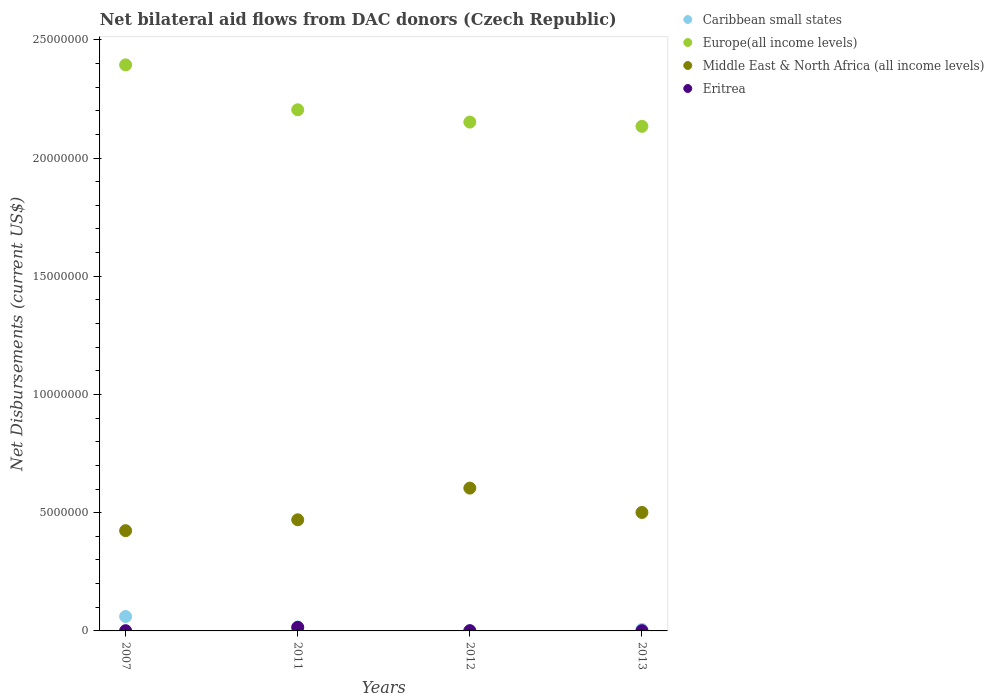Is the number of dotlines equal to the number of legend labels?
Give a very brief answer. Yes. Across all years, what is the maximum net bilateral aid flows in Europe(all income levels)?
Provide a short and direct response. 2.39e+07. Across all years, what is the minimum net bilateral aid flows in Europe(all income levels)?
Ensure brevity in your answer.  2.13e+07. In which year was the net bilateral aid flows in Europe(all income levels) maximum?
Offer a terse response. 2007. What is the total net bilateral aid flows in Middle East & North Africa (all income levels) in the graph?
Make the answer very short. 2.00e+07. What is the difference between the net bilateral aid flows in Europe(all income levels) in 2012 and that in 2013?
Offer a terse response. 1.80e+05. What is the difference between the net bilateral aid flows in Europe(all income levels) in 2012 and the net bilateral aid flows in Caribbean small states in 2007?
Keep it short and to the point. 2.09e+07. What is the average net bilateral aid flows in Eritrea per year?
Your answer should be compact. 4.50e+04. In the year 2011, what is the difference between the net bilateral aid flows in Europe(all income levels) and net bilateral aid flows in Middle East & North Africa (all income levels)?
Your response must be concise. 1.73e+07. In how many years, is the net bilateral aid flows in Eritrea greater than 4000000 US$?
Your answer should be compact. 0. What is the ratio of the net bilateral aid flows in Caribbean small states in 2007 to that in 2012?
Provide a succinct answer. 61. Is the net bilateral aid flows in Middle East & North Africa (all income levels) in 2007 less than that in 2011?
Ensure brevity in your answer.  Yes. What is the difference between the highest and the second highest net bilateral aid flows in Middle East & North Africa (all income levels)?
Ensure brevity in your answer.  1.03e+06. In how many years, is the net bilateral aid flows in Europe(all income levels) greater than the average net bilateral aid flows in Europe(all income levels) taken over all years?
Give a very brief answer. 1. Is the sum of the net bilateral aid flows in Middle East & North Africa (all income levels) in 2011 and 2013 greater than the maximum net bilateral aid flows in Europe(all income levels) across all years?
Offer a very short reply. No. Is it the case that in every year, the sum of the net bilateral aid flows in Middle East & North Africa (all income levels) and net bilateral aid flows in Europe(all income levels)  is greater than the sum of net bilateral aid flows in Eritrea and net bilateral aid flows in Caribbean small states?
Your answer should be compact. Yes. Does the net bilateral aid flows in Middle East & North Africa (all income levels) monotonically increase over the years?
Keep it short and to the point. No. Is the net bilateral aid flows in Europe(all income levels) strictly less than the net bilateral aid flows in Caribbean small states over the years?
Provide a short and direct response. No. How many dotlines are there?
Your answer should be very brief. 4. How many years are there in the graph?
Offer a terse response. 4. What is the difference between two consecutive major ticks on the Y-axis?
Your response must be concise. 5.00e+06. Are the values on the major ticks of Y-axis written in scientific E-notation?
Make the answer very short. No. Where does the legend appear in the graph?
Keep it short and to the point. Top right. How are the legend labels stacked?
Your answer should be compact. Vertical. What is the title of the graph?
Keep it short and to the point. Net bilateral aid flows from DAC donors (Czech Republic). Does "Jamaica" appear as one of the legend labels in the graph?
Provide a succinct answer. No. What is the label or title of the Y-axis?
Make the answer very short. Net Disbursements (current US$). What is the Net Disbursements (current US$) of Caribbean small states in 2007?
Make the answer very short. 6.10e+05. What is the Net Disbursements (current US$) in Europe(all income levels) in 2007?
Your answer should be very brief. 2.39e+07. What is the Net Disbursements (current US$) of Middle East & North Africa (all income levels) in 2007?
Ensure brevity in your answer.  4.24e+06. What is the Net Disbursements (current US$) of Europe(all income levels) in 2011?
Your response must be concise. 2.20e+07. What is the Net Disbursements (current US$) of Middle East & North Africa (all income levels) in 2011?
Provide a short and direct response. 4.70e+06. What is the Net Disbursements (current US$) of Caribbean small states in 2012?
Offer a terse response. 10000. What is the Net Disbursements (current US$) in Europe(all income levels) in 2012?
Offer a terse response. 2.15e+07. What is the Net Disbursements (current US$) in Middle East & North Africa (all income levels) in 2012?
Provide a succinct answer. 6.04e+06. What is the Net Disbursements (current US$) of Eritrea in 2012?
Offer a terse response. 10000. What is the Net Disbursements (current US$) in Caribbean small states in 2013?
Ensure brevity in your answer.  6.00e+04. What is the Net Disbursements (current US$) in Europe(all income levels) in 2013?
Provide a succinct answer. 2.13e+07. What is the Net Disbursements (current US$) of Middle East & North Africa (all income levels) in 2013?
Offer a very short reply. 5.01e+06. What is the Net Disbursements (current US$) in Eritrea in 2013?
Ensure brevity in your answer.  10000. Across all years, what is the maximum Net Disbursements (current US$) of Europe(all income levels)?
Provide a succinct answer. 2.39e+07. Across all years, what is the maximum Net Disbursements (current US$) of Middle East & North Africa (all income levels)?
Keep it short and to the point. 6.04e+06. Across all years, what is the minimum Net Disbursements (current US$) of Europe(all income levels)?
Your response must be concise. 2.13e+07. Across all years, what is the minimum Net Disbursements (current US$) in Middle East & North Africa (all income levels)?
Provide a short and direct response. 4.24e+06. What is the total Net Disbursements (current US$) of Caribbean small states in the graph?
Offer a terse response. 8.50e+05. What is the total Net Disbursements (current US$) of Europe(all income levels) in the graph?
Provide a succinct answer. 8.88e+07. What is the total Net Disbursements (current US$) of Middle East & North Africa (all income levels) in the graph?
Ensure brevity in your answer.  2.00e+07. What is the difference between the Net Disbursements (current US$) in Europe(all income levels) in 2007 and that in 2011?
Your answer should be very brief. 1.90e+06. What is the difference between the Net Disbursements (current US$) of Middle East & North Africa (all income levels) in 2007 and that in 2011?
Keep it short and to the point. -4.60e+05. What is the difference between the Net Disbursements (current US$) in Eritrea in 2007 and that in 2011?
Your answer should be compact. -1.40e+05. What is the difference between the Net Disbursements (current US$) in Europe(all income levels) in 2007 and that in 2012?
Provide a short and direct response. 2.42e+06. What is the difference between the Net Disbursements (current US$) in Middle East & North Africa (all income levels) in 2007 and that in 2012?
Your response must be concise. -1.80e+06. What is the difference between the Net Disbursements (current US$) of Eritrea in 2007 and that in 2012?
Make the answer very short. 0. What is the difference between the Net Disbursements (current US$) in Caribbean small states in 2007 and that in 2013?
Your answer should be very brief. 5.50e+05. What is the difference between the Net Disbursements (current US$) in Europe(all income levels) in 2007 and that in 2013?
Offer a terse response. 2.60e+06. What is the difference between the Net Disbursements (current US$) in Middle East & North Africa (all income levels) in 2007 and that in 2013?
Offer a terse response. -7.70e+05. What is the difference between the Net Disbursements (current US$) in Europe(all income levels) in 2011 and that in 2012?
Provide a succinct answer. 5.20e+05. What is the difference between the Net Disbursements (current US$) of Middle East & North Africa (all income levels) in 2011 and that in 2012?
Keep it short and to the point. -1.34e+06. What is the difference between the Net Disbursements (current US$) of Europe(all income levels) in 2011 and that in 2013?
Offer a terse response. 7.00e+05. What is the difference between the Net Disbursements (current US$) in Middle East & North Africa (all income levels) in 2011 and that in 2013?
Provide a succinct answer. -3.10e+05. What is the difference between the Net Disbursements (current US$) in Caribbean small states in 2012 and that in 2013?
Offer a terse response. -5.00e+04. What is the difference between the Net Disbursements (current US$) in Middle East & North Africa (all income levels) in 2012 and that in 2013?
Give a very brief answer. 1.03e+06. What is the difference between the Net Disbursements (current US$) of Caribbean small states in 2007 and the Net Disbursements (current US$) of Europe(all income levels) in 2011?
Your answer should be very brief. -2.14e+07. What is the difference between the Net Disbursements (current US$) in Caribbean small states in 2007 and the Net Disbursements (current US$) in Middle East & North Africa (all income levels) in 2011?
Offer a very short reply. -4.09e+06. What is the difference between the Net Disbursements (current US$) in Caribbean small states in 2007 and the Net Disbursements (current US$) in Eritrea in 2011?
Your response must be concise. 4.60e+05. What is the difference between the Net Disbursements (current US$) of Europe(all income levels) in 2007 and the Net Disbursements (current US$) of Middle East & North Africa (all income levels) in 2011?
Offer a terse response. 1.92e+07. What is the difference between the Net Disbursements (current US$) of Europe(all income levels) in 2007 and the Net Disbursements (current US$) of Eritrea in 2011?
Your response must be concise. 2.38e+07. What is the difference between the Net Disbursements (current US$) in Middle East & North Africa (all income levels) in 2007 and the Net Disbursements (current US$) in Eritrea in 2011?
Make the answer very short. 4.09e+06. What is the difference between the Net Disbursements (current US$) in Caribbean small states in 2007 and the Net Disbursements (current US$) in Europe(all income levels) in 2012?
Keep it short and to the point. -2.09e+07. What is the difference between the Net Disbursements (current US$) in Caribbean small states in 2007 and the Net Disbursements (current US$) in Middle East & North Africa (all income levels) in 2012?
Your response must be concise. -5.43e+06. What is the difference between the Net Disbursements (current US$) in Europe(all income levels) in 2007 and the Net Disbursements (current US$) in Middle East & North Africa (all income levels) in 2012?
Give a very brief answer. 1.79e+07. What is the difference between the Net Disbursements (current US$) of Europe(all income levels) in 2007 and the Net Disbursements (current US$) of Eritrea in 2012?
Provide a succinct answer. 2.39e+07. What is the difference between the Net Disbursements (current US$) of Middle East & North Africa (all income levels) in 2007 and the Net Disbursements (current US$) of Eritrea in 2012?
Make the answer very short. 4.23e+06. What is the difference between the Net Disbursements (current US$) of Caribbean small states in 2007 and the Net Disbursements (current US$) of Europe(all income levels) in 2013?
Keep it short and to the point. -2.07e+07. What is the difference between the Net Disbursements (current US$) in Caribbean small states in 2007 and the Net Disbursements (current US$) in Middle East & North Africa (all income levels) in 2013?
Provide a succinct answer. -4.40e+06. What is the difference between the Net Disbursements (current US$) of Caribbean small states in 2007 and the Net Disbursements (current US$) of Eritrea in 2013?
Your response must be concise. 6.00e+05. What is the difference between the Net Disbursements (current US$) of Europe(all income levels) in 2007 and the Net Disbursements (current US$) of Middle East & North Africa (all income levels) in 2013?
Offer a terse response. 1.89e+07. What is the difference between the Net Disbursements (current US$) of Europe(all income levels) in 2007 and the Net Disbursements (current US$) of Eritrea in 2013?
Give a very brief answer. 2.39e+07. What is the difference between the Net Disbursements (current US$) of Middle East & North Africa (all income levels) in 2007 and the Net Disbursements (current US$) of Eritrea in 2013?
Keep it short and to the point. 4.23e+06. What is the difference between the Net Disbursements (current US$) in Caribbean small states in 2011 and the Net Disbursements (current US$) in Europe(all income levels) in 2012?
Offer a terse response. -2.14e+07. What is the difference between the Net Disbursements (current US$) in Caribbean small states in 2011 and the Net Disbursements (current US$) in Middle East & North Africa (all income levels) in 2012?
Your answer should be very brief. -5.87e+06. What is the difference between the Net Disbursements (current US$) in Europe(all income levels) in 2011 and the Net Disbursements (current US$) in Middle East & North Africa (all income levels) in 2012?
Offer a terse response. 1.60e+07. What is the difference between the Net Disbursements (current US$) of Europe(all income levels) in 2011 and the Net Disbursements (current US$) of Eritrea in 2012?
Offer a very short reply. 2.20e+07. What is the difference between the Net Disbursements (current US$) in Middle East & North Africa (all income levels) in 2011 and the Net Disbursements (current US$) in Eritrea in 2012?
Your answer should be compact. 4.69e+06. What is the difference between the Net Disbursements (current US$) of Caribbean small states in 2011 and the Net Disbursements (current US$) of Europe(all income levels) in 2013?
Your answer should be very brief. -2.12e+07. What is the difference between the Net Disbursements (current US$) in Caribbean small states in 2011 and the Net Disbursements (current US$) in Middle East & North Africa (all income levels) in 2013?
Offer a terse response. -4.84e+06. What is the difference between the Net Disbursements (current US$) of Caribbean small states in 2011 and the Net Disbursements (current US$) of Eritrea in 2013?
Your answer should be compact. 1.60e+05. What is the difference between the Net Disbursements (current US$) of Europe(all income levels) in 2011 and the Net Disbursements (current US$) of Middle East & North Africa (all income levels) in 2013?
Your answer should be compact. 1.70e+07. What is the difference between the Net Disbursements (current US$) of Europe(all income levels) in 2011 and the Net Disbursements (current US$) of Eritrea in 2013?
Provide a short and direct response. 2.20e+07. What is the difference between the Net Disbursements (current US$) of Middle East & North Africa (all income levels) in 2011 and the Net Disbursements (current US$) of Eritrea in 2013?
Offer a very short reply. 4.69e+06. What is the difference between the Net Disbursements (current US$) in Caribbean small states in 2012 and the Net Disbursements (current US$) in Europe(all income levels) in 2013?
Make the answer very short. -2.13e+07. What is the difference between the Net Disbursements (current US$) of Caribbean small states in 2012 and the Net Disbursements (current US$) of Middle East & North Africa (all income levels) in 2013?
Offer a very short reply. -5.00e+06. What is the difference between the Net Disbursements (current US$) of Europe(all income levels) in 2012 and the Net Disbursements (current US$) of Middle East & North Africa (all income levels) in 2013?
Keep it short and to the point. 1.65e+07. What is the difference between the Net Disbursements (current US$) in Europe(all income levels) in 2012 and the Net Disbursements (current US$) in Eritrea in 2013?
Offer a terse response. 2.15e+07. What is the difference between the Net Disbursements (current US$) of Middle East & North Africa (all income levels) in 2012 and the Net Disbursements (current US$) of Eritrea in 2013?
Give a very brief answer. 6.03e+06. What is the average Net Disbursements (current US$) of Caribbean small states per year?
Offer a very short reply. 2.12e+05. What is the average Net Disbursements (current US$) in Europe(all income levels) per year?
Provide a succinct answer. 2.22e+07. What is the average Net Disbursements (current US$) of Middle East & North Africa (all income levels) per year?
Offer a terse response. 5.00e+06. What is the average Net Disbursements (current US$) of Eritrea per year?
Ensure brevity in your answer.  4.50e+04. In the year 2007, what is the difference between the Net Disbursements (current US$) of Caribbean small states and Net Disbursements (current US$) of Europe(all income levels)?
Keep it short and to the point. -2.33e+07. In the year 2007, what is the difference between the Net Disbursements (current US$) of Caribbean small states and Net Disbursements (current US$) of Middle East & North Africa (all income levels)?
Give a very brief answer. -3.63e+06. In the year 2007, what is the difference between the Net Disbursements (current US$) in Europe(all income levels) and Net Disbursements (current US$) in Middle East & North Africa (all income levels)?
Provide a short and direct response. 1.97e+07. In the year 2007, what is the difference between the Net Disbursements (current US$) in Europe(all income levels) and Net Disbursements (current US$) in Eritrea?
Provide a succinct answer. 2.39e+07. In the year 2007, what is the difference between the Net Disbursements (current US$) in Middle East & North Africa (all income levels) and Net Disbursements (current US$) in Eritrea?
Provide a short and direct response. 4.23e+06. In the year 2011, what is the difference between the Net Disbursements (current US$) of Caribbean small states and Net Disbursements (current US$) of Europe(all income levels)?
Make the answer very short. -2.19e+07. In the year 2011, what is the difference between the Net Disbursements (current US$) of Caribbean small states and Net Disbursements (current US$) of Middle East & North Africa (all income levels)?
Offer a very short reply. -4.53e+06. In the year 2011, what is the difference between the Net Disbursements (current US$) of Caribbean small states and Net Disbursements (current US$) of Eritrea?
Give a very brief answer. 2.00e+04. In the year 2011, what is the difference between the Net Disbursements (current US$) of Europe(all income levels) and Net Disbursements (current US$) of Middle East & North Africa (all income levels)?
Provide a short and direct response. 1.73e+07. In the year 2011, what is the difference between the Net Disbursements (current US$) in Europe(all income levels) and Net Disbursements (current US$) in Eritrea?
Offer a very short reply. 2.19e+07. In the year 2011, what is the difference between the Net Disbursements (current US$) in Middle East & North Africa (all income levels) and Net Disbursements (current US$) in Eritrea?
Ensure brevity in your answer.  4.55e+06. In the year 2012, what is the difference between the Net Disbursements (current US$) in Caribbean small states and Net Disbursements (current US$) in Europe(all income levels)?
Offer a very short reply. -2.15e+07. In the year 2012, what is the difference between the Net Disbursements (current US$) in Caribbean small states and Net Disbursements (current US$) in Middle East & North Africa (all income levels)?
Give a very brief answer. -6.03e+06. In the year 2012, what is the difference between the Net Disbursements (current US$) of Caribbean small states and Net Disbursements (current US$) of Eritrea?
Your response must be concise. 0. In the year 2012, what is the difference between the Net Disbursements (current US$) in Europe(all income levels) and Net Disbursements (current US$) in Middle East & North Africa (all income levels)?
Offer a very short reply. 1.55e+07. In the year 2012, what is the difference between the Net Disbursements (current US$) of Europe(all income levels) and Net Disbursements (current US$) of Eritrea?
Offer a very short reply. 2.15e+07. In the year 2012, what is the difference between the Net Disbursements (current US$) in Middle East & North Africa (all income levels) and Net Disbursements (current US$) in Eritrea?
Offer a terse response. 6.03e+06. In the year 2013, what is the difference between the Net Disbursements (current US$) of Caribbean small states and Net Disbursements (current US$) of Europe(all income levels)?
Offer a terse response. -2.13e+07. In the year 2013, what is the difference between the Net Disbursements (current US$) in Caribbean small states and Net Disbursements (current US$) in Middle East & North Africa (all income levels)?
Provide a short and direct response. -4.95e+06. In the year 2013, what is the difference between the Net Disbursements (current US$) in Caribbean small states and Net Disbursements (current US$) in Eritrea?
Make the answer very short. 5.00e+04. In the year 2013, what is the difference between the Net Disbursements (current US$) of Europe(all income levels) and Net Disbursements (current US$) of Middle East & North Africa (all income levels)?
Ensure brevity in your answer.  1.63e+07. In the year 2013, what is the difference between the Net Disbursements (current US$) of Europe(all income levels) and Net Disbursements (current US$) of Eritrea?
Your answer should be compact. 2.13e+07. In the year 2013, what is the difference between the Net Disbursements (current US$) in Middle East & North Africa (all income levels) and Net Disbursements (current US$) in Eritrea?
Ensure brevity in your answer.  5.00e+06. What is the ratio of the Net Disbursements (current US$) in Caribbean small states in 2007 to that in 2011?
Your response must be concise. 3.59. What is the ratio of the Net Disbursements (current US$) in Europe(all income levels) in 2007 to that in 2011?
Your answer should be compact. 1.09. What is the ratio of the Net Disbursements (current US$) in Middle East & North Africa (all income levels) in 2007 to that in 2011?
Give a very brief answer. 0.9. What is the ratio of the Net Disbursements (current US$) of Eritrea in 2007 to that in 2011?
Your answer should be compact. 0.07. What is the ratio of the Net Disbursements (current US$) of Caribbean small states in 2007 to that in 2012?
Offer a very short reply. 61. What is the ratio of the Net Disbursements (current US$) of Europe(all income levels) in 2007 to that in 2012?
Provide a short and direct response. 1.11. What is the ratio of the Net Disbursements (current US$) of Middle East & North Africa (all income levels) in 2007 to that in 2012?
Your answer should be very brief. 0.7. What is the ratio of the Net Disbursements (current US$) of Eritrea in 2007 to that in 2012?
Provide a succinct answer. 1. What is the ratio of the Net Disbursements (current US$) in Caribbean small states in 2007 to that in 2013?
Provide a short and direct response. 10.17. What is the ratio of the Net Disbursements (current US$) of Europe(all income levels) in 2007 to that in 2013?
Provide a short and direct response. 1.12. What is the ratio of the Net Disbursements (current US$) in Middle East & North Africa (all income levels) in 2007 to that in 2013?
Your answer should be compact. 0.85. What is the ratio of the Net Disbursements (current US$) of Eritrea in 2007 to that in 2013?
Make the answer very short. 1. What is the ratio of the Net Disbursements (current US$) of Caribbean small states in 2011 to that in 2012?
Give a very brief answer. 17. What is the ratio of the Net Disbursements (current US$) of Europe(all income levels) in 2011 to that in 2012?
Provide a succinct answer. 1.02. What is the ratio of the Net Disbursements (current US$) in Middle East & North Africa (all income levels) in 2011 to that in 2012?
Your response must be concise. 0.78. What is the ratio of the Net Disbursements (current US$) in Caribbean small states in 2011 to that in 2013?
Provide a short and direct response. 2.83. What is the ratio of the Net Disbursements (current US$) in Europe(all income levels) in 2011 to that in 2013?
Offer a terse response. 1.03. What is the ratio of the Net Disbursements (current US$) in Middle East & North Africa (all income levels) in 2011 to that in 2013?
Your response must be concise. 0.94. What is the ratio of the Net Disbursements (current US$) in Europe(all income levels) in 2012 to that in 2013?
Provide a succinct answer. 1.01. What is the ratio of the Net Disbursements (current US$) in Middle East & North Africa (all income levels) in 2012 to that in 2013?
Your response must be concise. 1.21. What is the ratio of the Net Disbursements (current US$) in Eritrea in 2012 to that in 2013?
Ensure brevity in your answer.  1. What is the difference between the highest and the second highest Net Disbursements (current US$) of Caribbean small states?
Provide a succinct answer. 4.40e+05. What is the difference between the highest and the second highest Net Disbursements (current US$) in Europe(all income levels)?
Ensure brevity in your answer.  1.90e+06. What is the difference between the highest and the second highest Net Disbursements (current US$) in Middle East & North Africa (all income levels)?
Your answer should be compact. 1.03e+06. What is the difference between the highest and the second highest Net Disbursements (current US$) of Eritrea?
Your answer should be very brief. 1.40e+05. What is the difference between the highest and the lowest Net Disbursements (current US$) of Europe(all income levels)?
Ensure brevity in your answer.  2.60e+06. What is the difference between the highest and the lowest Net Disbursements (current US$) of Middle East & North Africa (all income levels)?
Make the answer very short. 1.80e+06. 